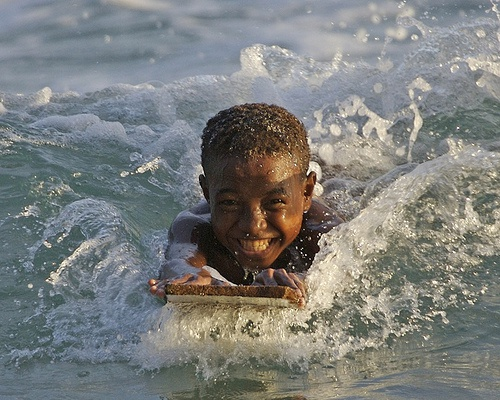Describe the objects in this image and their specific colors. I can see people in darkgray, black, maroon, and gray tones and surfboard in darkgray, maroon, tan, and gray tones in this image. 